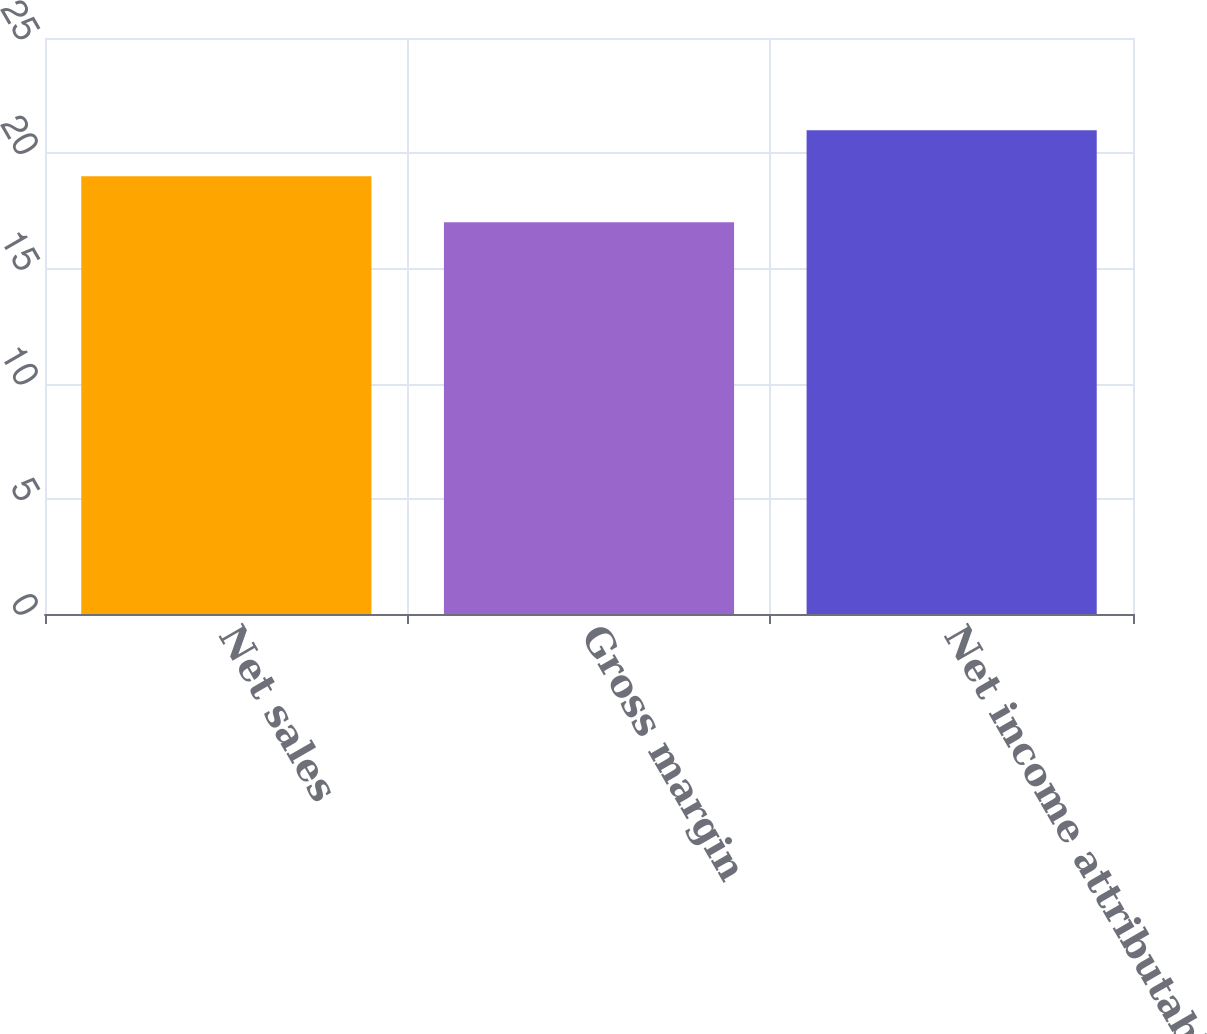<chart> <loc_0><loc_0><loc_500><loc_500><bar_chart><fcel>Net sales<fcel>Gross margin<fcel>Net income attributable to<nl><fcel>19<fcel>17<fcel>21<nl></chart> 